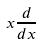<formula> <loc_0><loc_0><loc_500><loc_500>x \frac { d } { d x }</formula> 